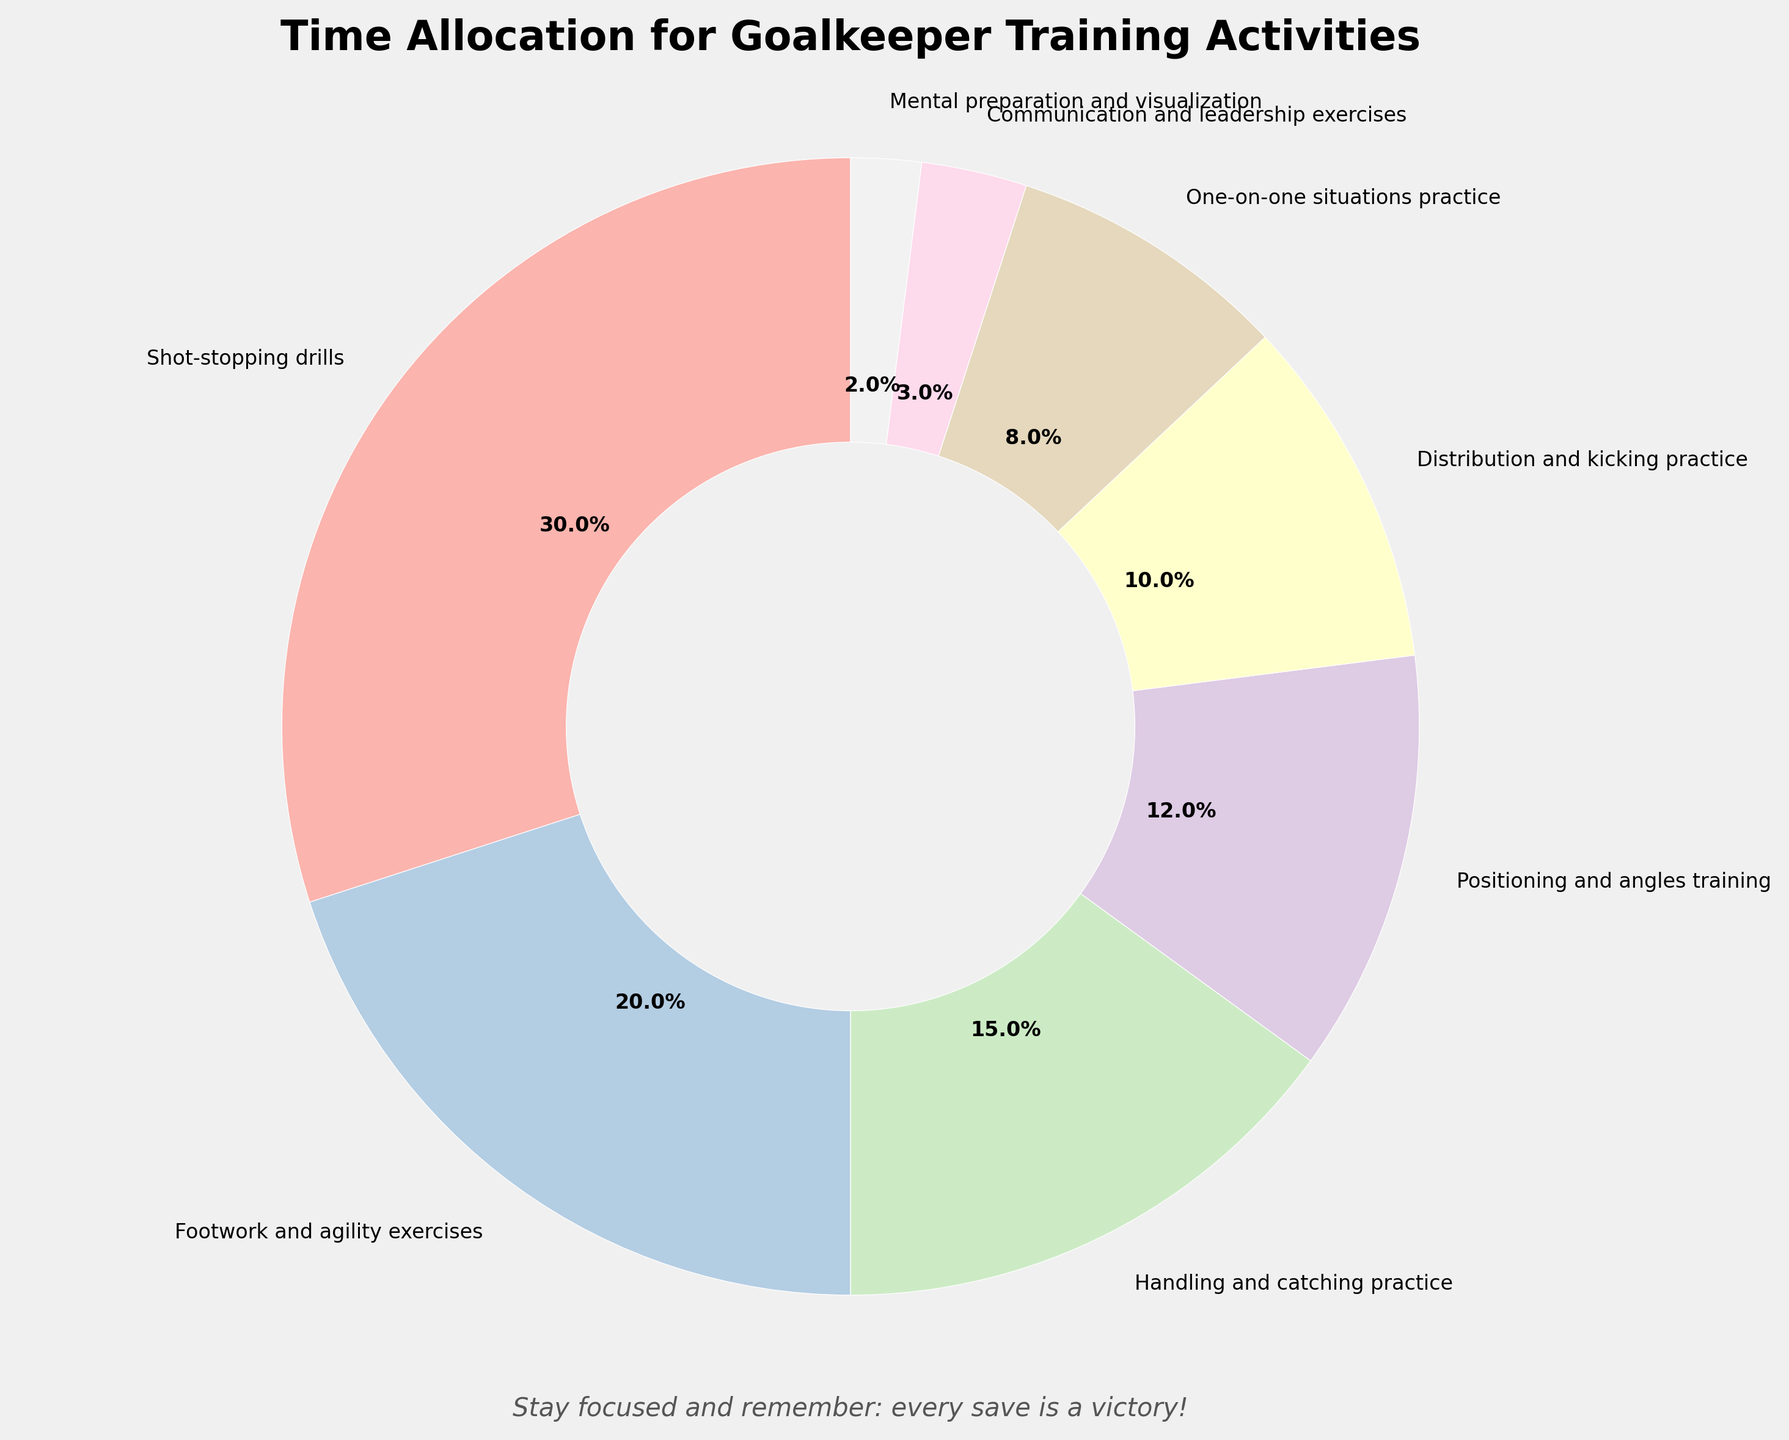What's the largest portion of the pie chart? By observing the pie chart, the largest wedge represents the activity with the highest time percentage. The wedge labeled "Shot-stopping drills" is the largest, at 30%.
Answer: Shot-stopping drills How much total time is spent on communication and mental preparation combined? Locate the segments for "Communication and leadership exercises" (3%) and "Mental preparation and visualization" (2%). Adding these percentages gives 3% + 2% = 5%.
Answer: 5% Which activity has a smaller allocation: Distribution and kicking practice or Positioning and angles training? By comparing the wedges for "Distribution and kicking practice" (10%) and "Positioning and angles training" (12%), we see that "Distribution and kicking practice" has a smaller allocation.
Answer: Distribution and kicking practice How much more time is spent on footwork and agility exercises compared to handling and catching practice? The wedge for "Footwork and agility exercises" is 20% and the wedge for "Handling and catching practice" is 15%. The difference is 20% - 15% = 5%.
Answer: 5% What fraction of the training time is dedicated to handling and catching practice? The wedge for "Handling and catching practice" is 15%. This implies it takes up 15% of the total 100% training time, which is 15/100 or 3/20.
Answer: 3/20 Rank the three smallest training activities in order of their time allocation. The three wedges with the smallest percentages are "Mental preparation and visualization" (2%), "Communication and leadership exercises" (3%), and "One-on-one situations practice" (8%). Arranging from smallest to largest: Mental preparation and visualization, Communication and leadership exercises, One-on-one situations practice.
Answer: 1. Mental preparation and visualization 2. Communication and leadership exercises 3. One-on-one situations practice What is the combined percentage of activities involving ball handling (handling and catching practice, shot-stopping drills)? The segments for "Handling and catching practice" (15%) and "Shot-stopping drills" (30%). Adding these percentages yields 15% + 30% = 45%.
Answer: 45% Which activities occupy more than 10% of the training time? The activities with percentages greater than 10% are easily identifiable by their larger wedges. "Shot-stopping drills" (30%), "Footwork and agility exercises" (20%), "Handling and catching practice" (15%), and "Positioning and angles training" (12%).
Answer: Shot-stopping drills, Footwork and agility exercises, Handling and catching practice, Positioning and angles training How much more time is spent on shot-stopping drills compared to communication and leadership exercises? The pie chart shows "Shot-stopping drills" at 30% and "Communication and leadership exercises" at 3%. The difference is 30% - 3% = 27%.
Answer: 27% 